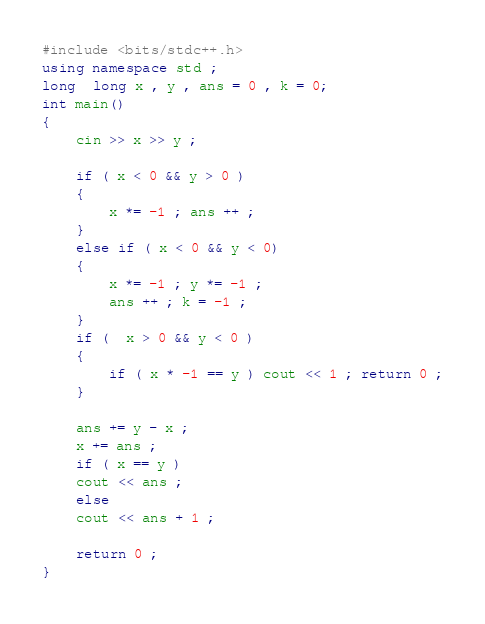<code> <loc_0><loc_0><loc_500><loc_500><_C++_>#include <bits/stdc++.h>
using namespace std ;
long  long x , y , ans = 0 , k = 0;
int main()
{
	cin >> x >> y ;
	
	if ( x < 0 && y > 0 ) 
	{
		x *= -1 ; ans ++ ;
	}
	else if ( x < 0 && y < 0)
	{
		x *= -1 ; y *= -1 ;
		ans ++ ; k = -1 ;
	}
	if (  x > 0 && y < 0 )
	{
		if ( x * -1 == y ) cout << 1 ; return 0 ;
	}
	
	ans += y - x ;
	x += ans ;
	if ( x == y )
	cout << ans ;
	else 
	cout << ans + 1 ;
	
	return 0 ;
}</code> 